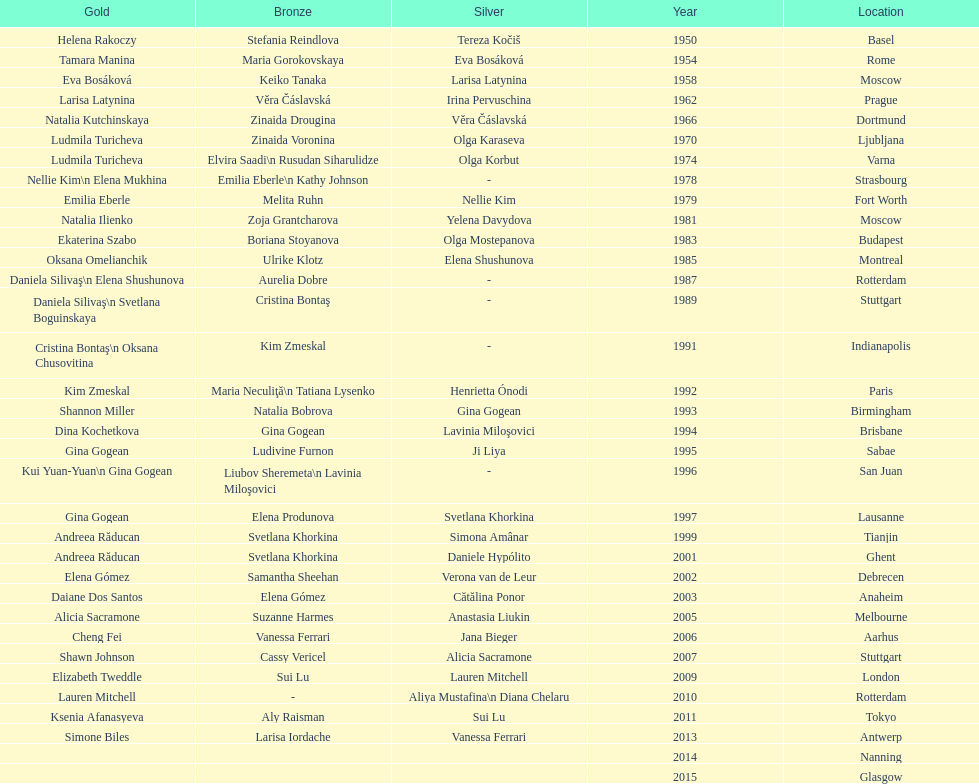How many times was the world artistic gymnastics championships held in the united states? 3. 